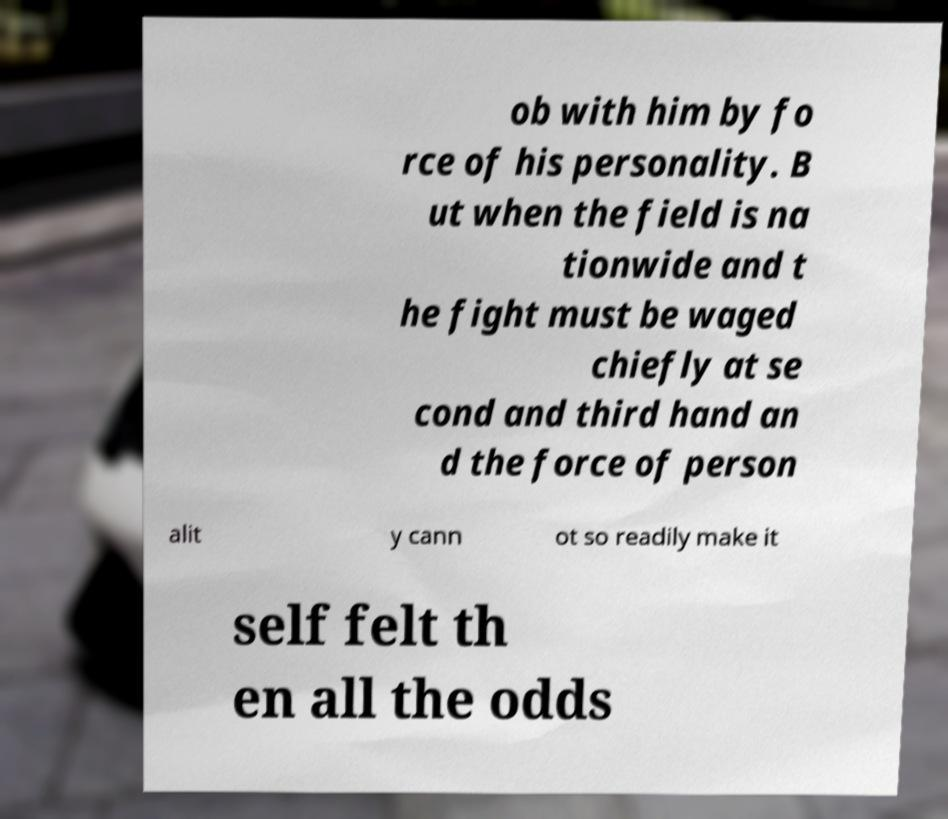Can you read and provide the text displayed in the image?This photo seems to have some interesting text. Can you extract and type it out for me? ob with him by fo rce of his personality. B ut when the field is na tionwide and t he fight must be waged chiefly at se cond and third hand an d the force of person alit y cann ot so readily make it self felt th en all the odds 